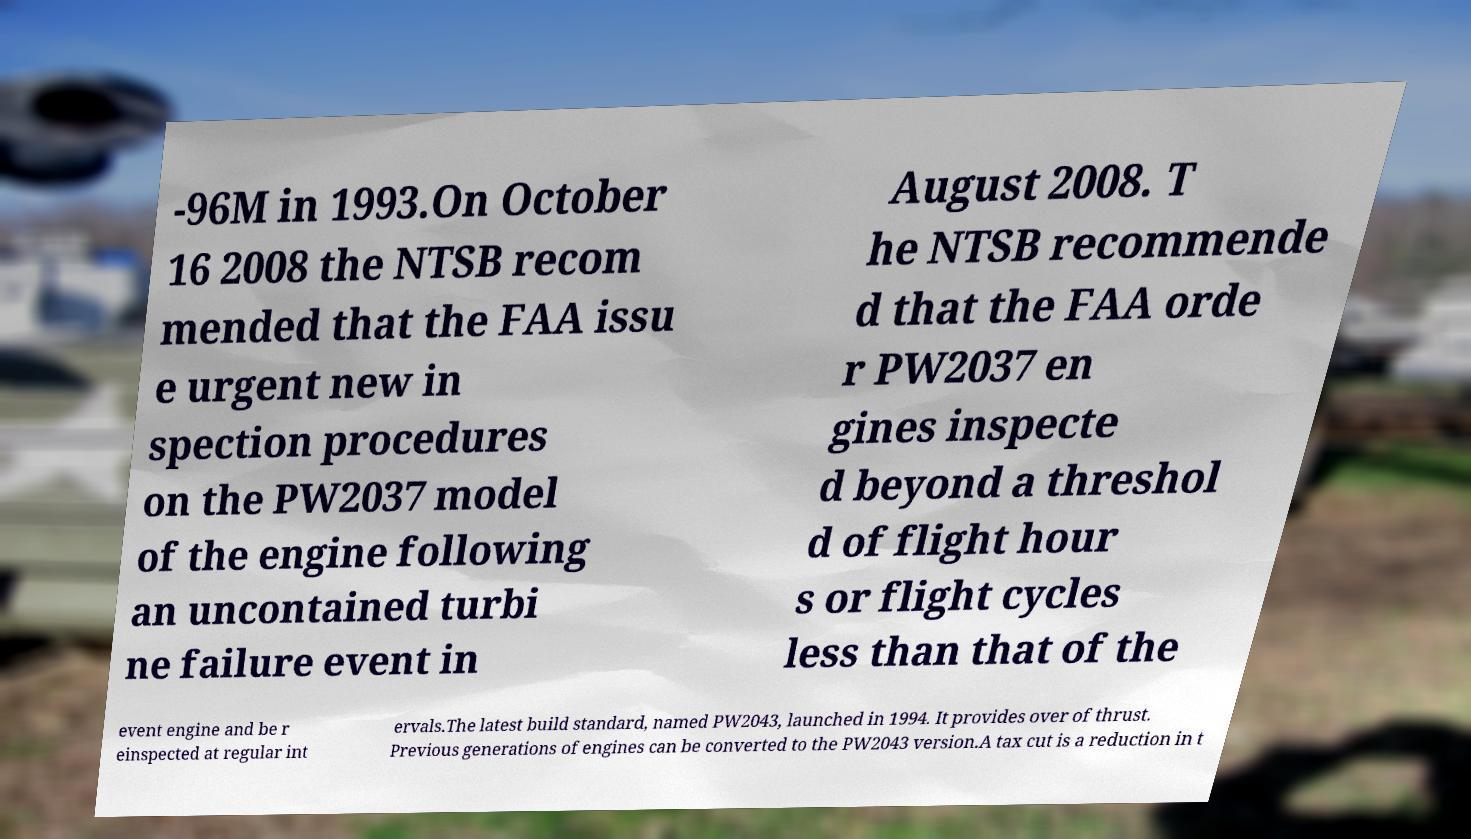Can you read and provide the text displayed in the image?This photo seems to have some interesting text. Can you extract and type it out for me? -96M in 1993.On October 16 2008 the NTSB recom mended that the FAA issu e urgent new in spection procedures on the PW2037 model of the engine following an uncontained turbi ne failure event in August 2008. T he NTSB recommende d that the FAA orde r PW2037 en gines inspecte d beyond a threshol d of flight hour s or flight cycles less than that of the event engine and be r einspected at regular int ervals.The latest build standard, named PW2043, launched in 1994. It provides over of thrust. Previous generations of engines can be converted to the PW2043 version.A tax cut is a reduction in t 